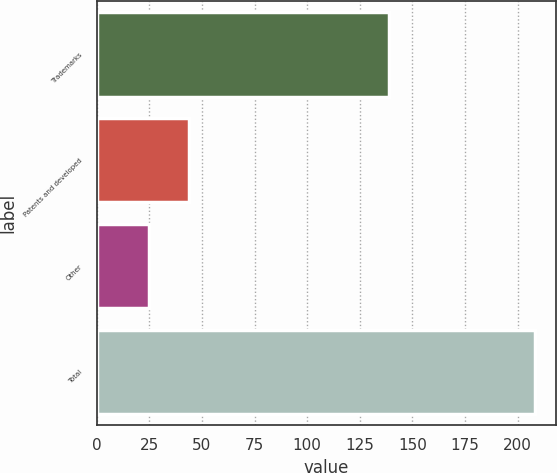<chart> <loc_0><loc_0><loc_500><loc_500><bar_chart><fcel>Trademarks<fcel>Patents and developed<fcel>Other<fcel>Total<nl><fcel>139<fcel>44<fcel>25<fcel>208<nl></chart> 